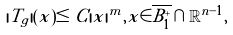Convert formula to latex. <formula><loc_0><loc_0><loc_500><loc_500>| T _ { g } | ( x ) \leq C | x | ^ { m } , x \in \overline { B ^ { + } _ { 1 } } \cap \mathbb { R } ^ { n - 1 } ,</formula> 